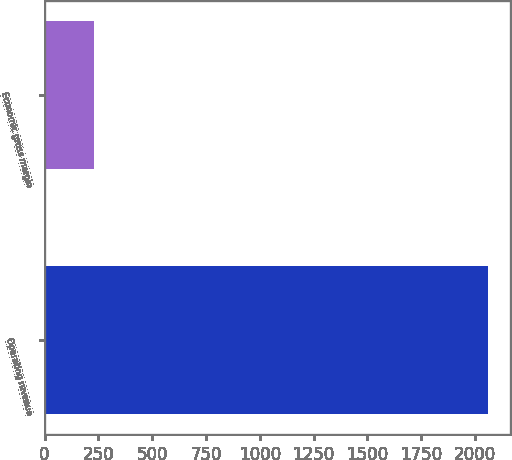Convert chart. <chart><loc_0><loc_0><loc_500><loc_500><bar_chart><fcel>Operating revenue<fcel>Economic gross margin<nl><fcel>2060<fcel>228<nl></chart> 